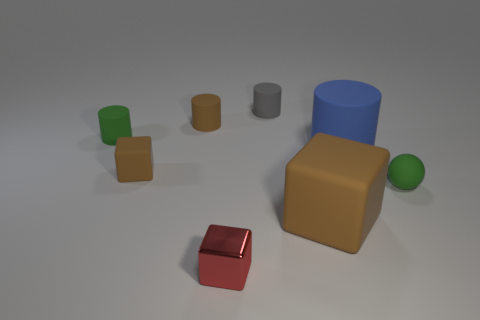Subtract all gray rubber cylinders. How many cylinders are left? 3 Subtract all blue cylinders. How many brown blocks are left? 2 Subtract all gray cylinders. How many cylinders are left? 3 Add 1 red matte cylinders. How many objects exist? 9 Subtract all balls. How many objects are left? 7 Subtract all brown cylinders. Subtract all blue cubes. How many cylinders are left? 3 Subtract all small things. Subtract all big yellow rubber balls. How many objects are left? 2 Add 6 brown cylinders. How many brown cylinders are left? 7 Add 2 tiny purple shiny spheres. How many tiny purple shiny spheres exist? 2 Subtract 1 blue cylinders. How many objects are left? 7 